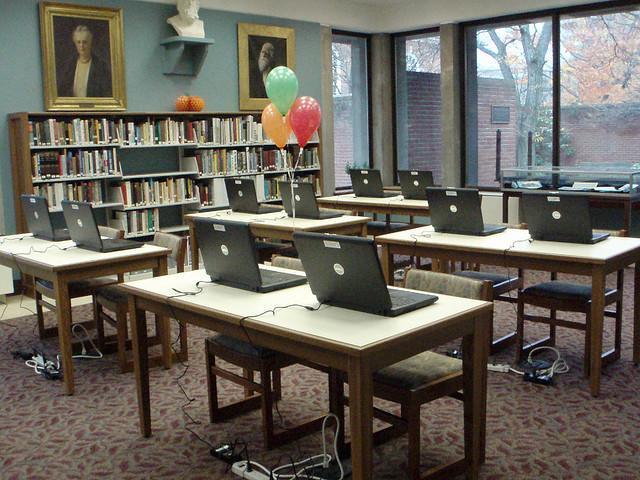What setting is this picture taken in?
Select the accurate answer and provide justification: `Answer: choice
Rationale: srationale.`
Options: Cafeteria, computer lab, classroom, laboratory. Answer: computer lab.
Rationale: A classroom with lap tops in it. 